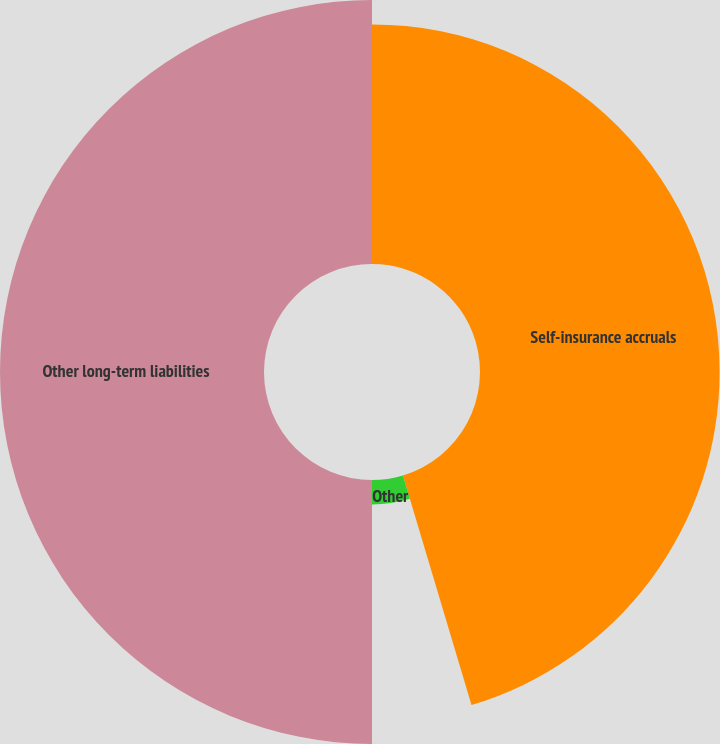<chart> <loc_0><loc_0><loc_500><loc_500><pie_chart><fcel>Self-insurance accruals<fcel>Other<fcel>Other long-term liabilities<nl><fcel>45.38%<fcel>4.62%<fcel>50.0%<nl></chart> 